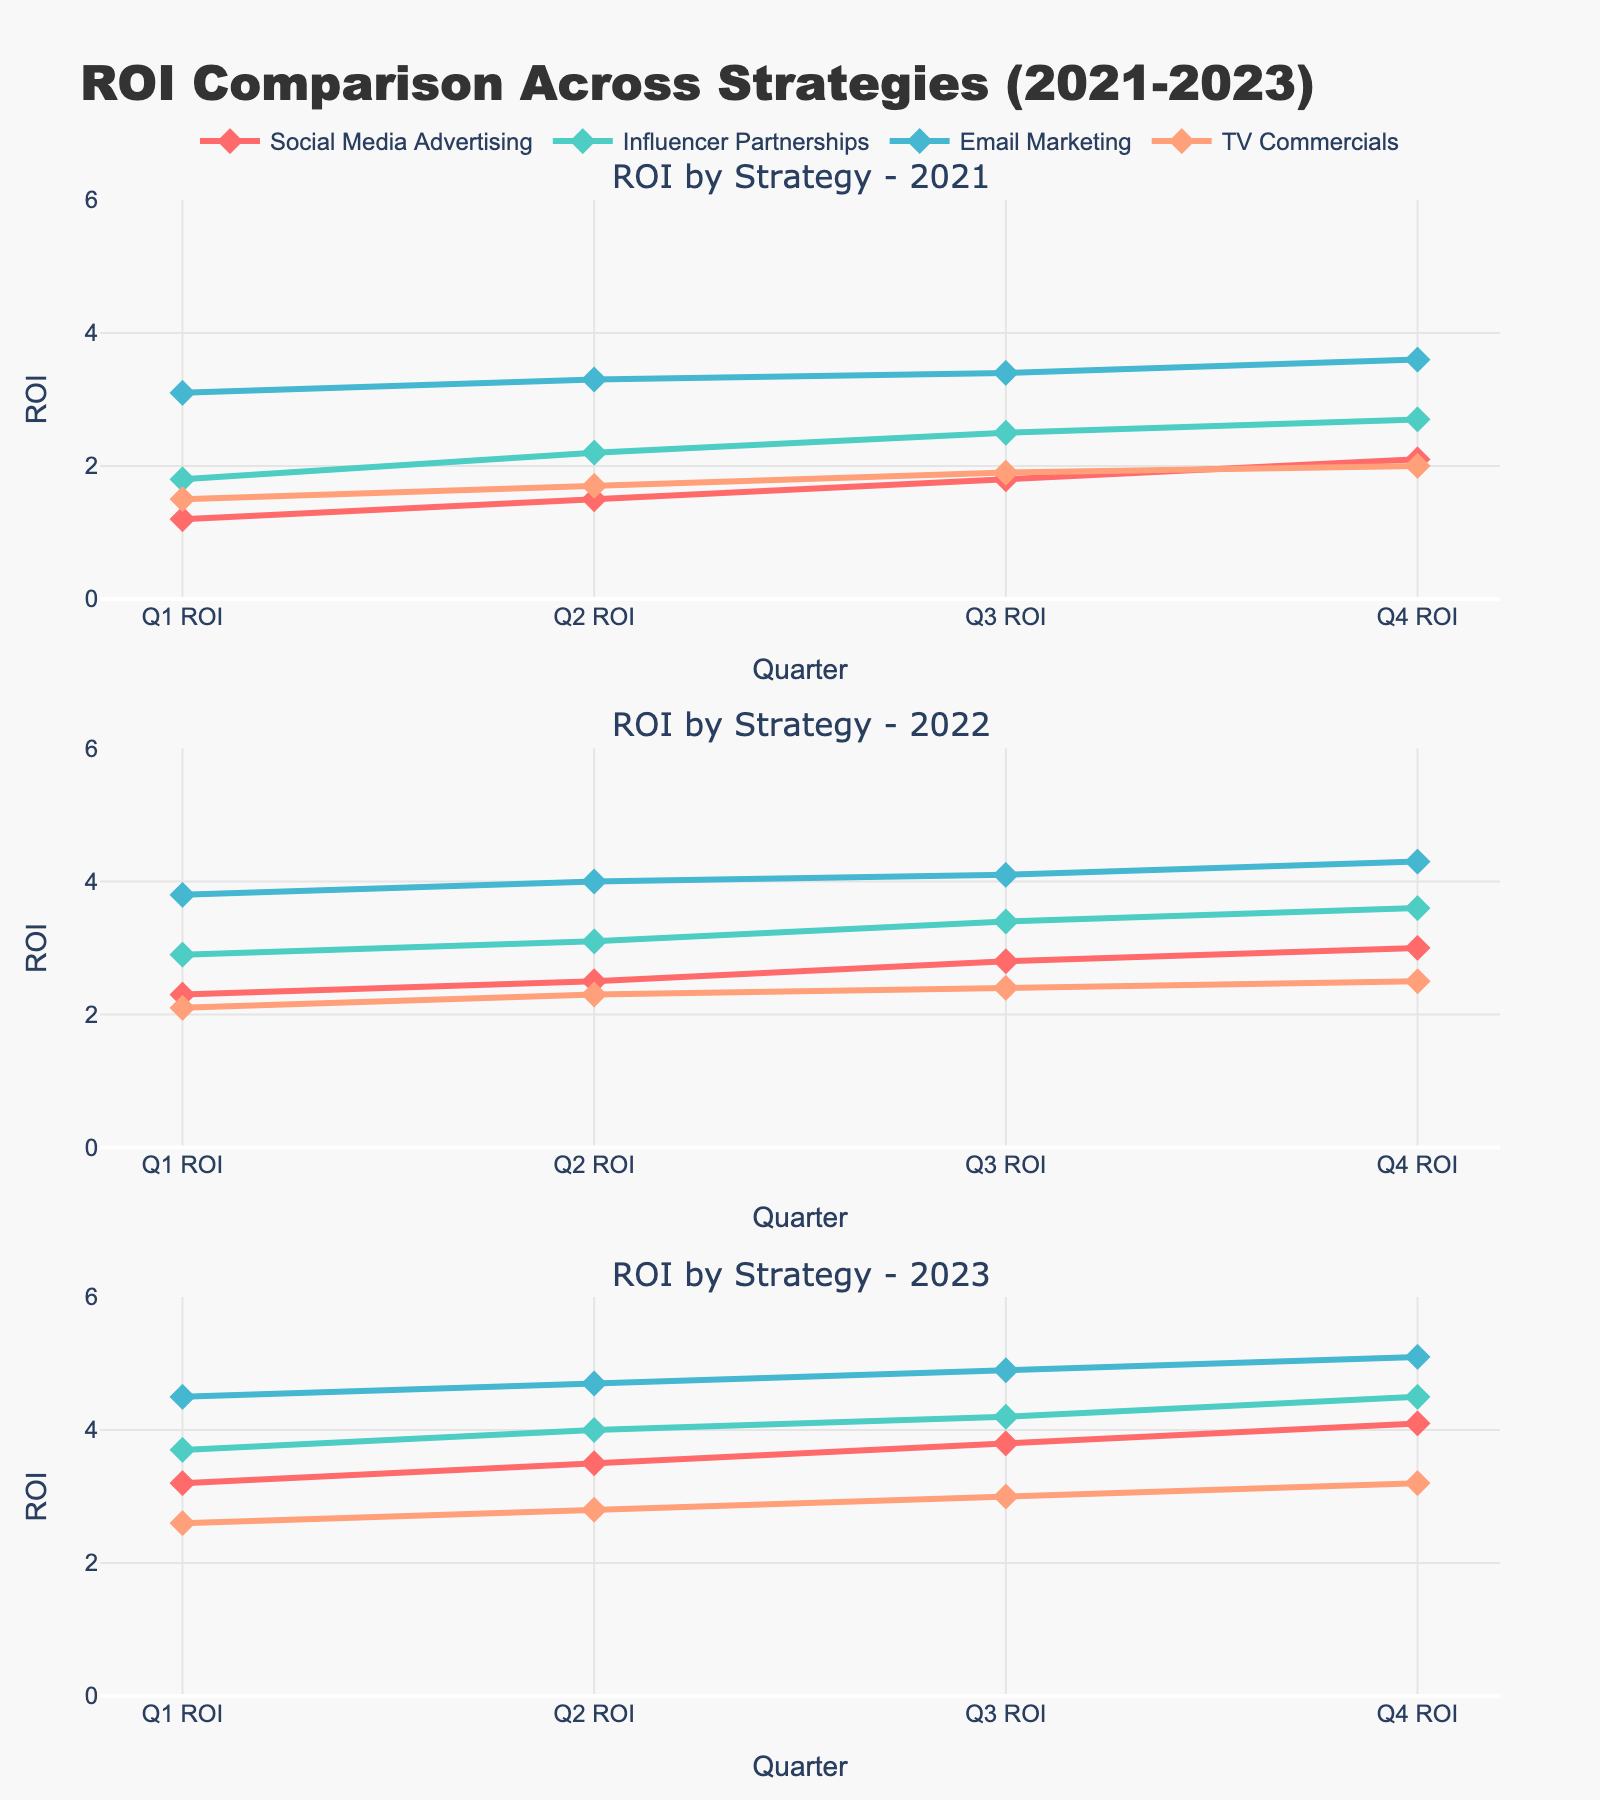What is the title of the figure? The title of the figure is displayed at the top of the plot. It is "ROI Comparison Across Strategies (2021-2023)".
Answer: ROI Comparison Across Strategies (2021-2023) Which year displayed the highest ROI for Email Marketing in Q4? To find this, we look at all Q4 ROI values for Email Marketing across the years. The Q4 ROI for Email Marketing is 3.6 in 2021, 4.3 in 2022, and 5.1 in 2023. The highest value is in 2023.
Answer: 2023 What is the difference in Q3 ROI between Influencer Partnerships and TV Commercials in 2022? In 2022, the Q3 ROI for Influencer Partnerships is 3.4 and for TV Commercials is 2.4. The difference is calculated by subtracting the Q3 ROI of TV Commercials from Influencer Partnerships: 3.4 - 2.4.
Answer: 1.0 Which strategy showed the most consistent ROI improvement across the quarters in 2021? We need to see which strategy displays a steady increase in ROI from Q1 to Q4 in 2021. Social Media Advertising: 1.2, 1.5, 1.8, 2.1; Influencer Partnerships: 1.8, 2.2, 2.5, 2.7; Email Marketing: 3.1, 3.3, 3.4, 3.6; TV Commercials: 1.5, 1.7, 1.9, 2.0. All strategies show improvement, but Email Marketing has the most consistent and uniform increase.
Answer: Email Marketing Compare the ROI trends of Social Media Advertising and Influencer Partnerships over the years 2021-2023. For Social Media Advertising: 2021 Q1 to Q4 are 1.2, 1.5, 1.8, 2.1; 2022 Q1 to Q4 are 2.3, 2.5, 2.8, 3.0; 2023 Q1 to Q4 are 3.2, 3.5, 3.8, 4.1. For Influencer Partnerships: 2021 Q1 to Q4 are 1.8, 2.2, 2.5, 2.7; 2022 Q1 to Q4 are 2.9, 3.1, 3.4, 3.6; 2023 Q1 to Q4 are 3.7, 4.0, 4.2, 4.5. Both show an increasing trend, but Influencer Partnerships starts higher and maintains a higher ROI overall.
Answer: Influencer Partnerships starts and maintains higher ROI What is the average Q1 ROI for all strategies in 2023? To find the average Q1 ROI for all strategies in 2023, sum the Q1 ROI of all strategies and divide by the number of strategies: (3.2 + 3.7 + 4.5 + 2.6)/4.
Answer: 3.5 In which year did TV Commercials show the smallest increase in ROI from Q1 to Q4? We compare the Q1 and Q4 ROI values for TV Commercials in each year. 2021: 1.5 to 2.0 (0.5 increase), 2022: 2.1 to 2.5 (0.4 increase), 2023: 2.6 to 3.2 (0.6 increase). The smallest increase is in 2022.
Answer: 2022 Which quarter typically had the highest ROI for Social Media Advertising over the years observed? Compare the Q1, Q2, Q3, and Q4 ROI values for Social Media Advertising across 2021 to 2023. The Q4 ROI values for each year (2.1 in 2021, 3.0 in 2022, 4.1 in 2023) are higher than those in Q1, Q2, and Q3 of their respective years.
Answer: Q4 